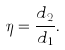<formula> <loc_0><loc_0><loc_500><loc_500>\eta = \frac { d _ { 2 } } { d _ { 1 } } .</formula> 